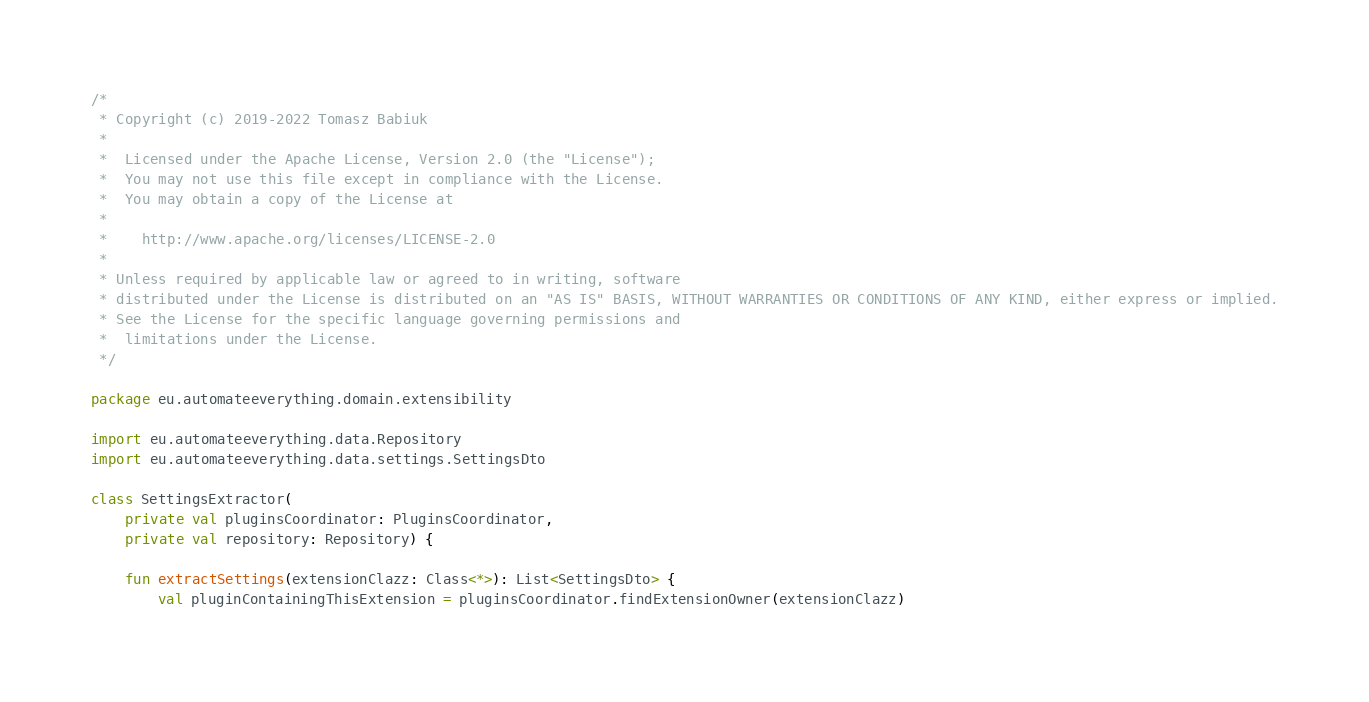Convert code to text. <code><loc_0><loc_0><loc_500><loc_500><_Kotlin_>/*
 * Copyright (c) 2019-2022 Tomasz Babiuk
 *
 *  Licensed under the Apache License, Version 2.0 (the "License");
 *  You may not use this file except in compliance with the License.
 *  You may obtain a copy of the License at
 *
 *    http://www.apache.org/licenses/LICENSE-2.0
 *
 * Unless required by applicable law or agreed to in writing, software
 * distributed under the License is distributed on an "AS IS" BASIS, WITHOUT WARRANTIES OR CONDITIONS OF ANY KIND, either express or implied.
 * See the License for the specific language governing permissions and
 *  limitations under the License.
 */

package eu.automateeverything.domain.extensibility

import eu.automateeverything.data.Repository
import eu.automateeverything.data.settings.SettingsDto

class SettingsExtractor(
    private val pluginsCoordinator: PluginsCoordinator,
    private val repository: Repository) {

    fun extractSettings(extensionClazz: Class<*>): List<SettingsDto> {
        val pluginContainingThisExtension = pluginsCoordinator.findExtensionOwner(extensionClazz)
</code> 